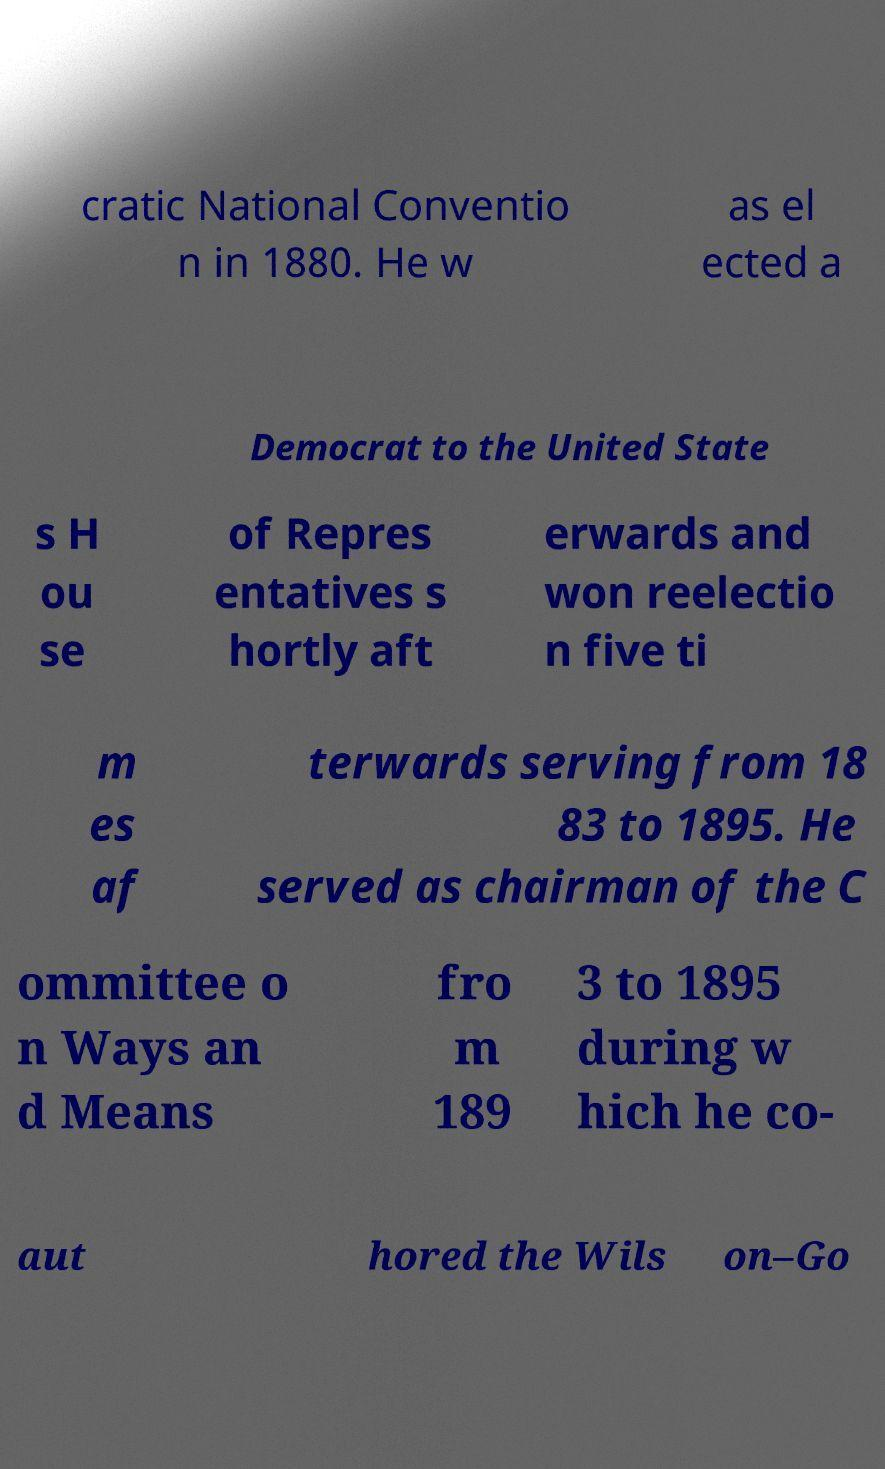What messages or text are displayed in this image? I need them in a readable, typed format. cratic National Conventio n in 1880. He w as el ected a Democrat to the United State s H ou se of Repres entatives s hortly aft erwards and won reelectio n five ti m es af terwards serving from 18 83 to 1895. He served as chairman of the C ommittee o n Ways an d Means fro m 189 3 to 1895 during w hich he co- aut hored the Wils on–Go 